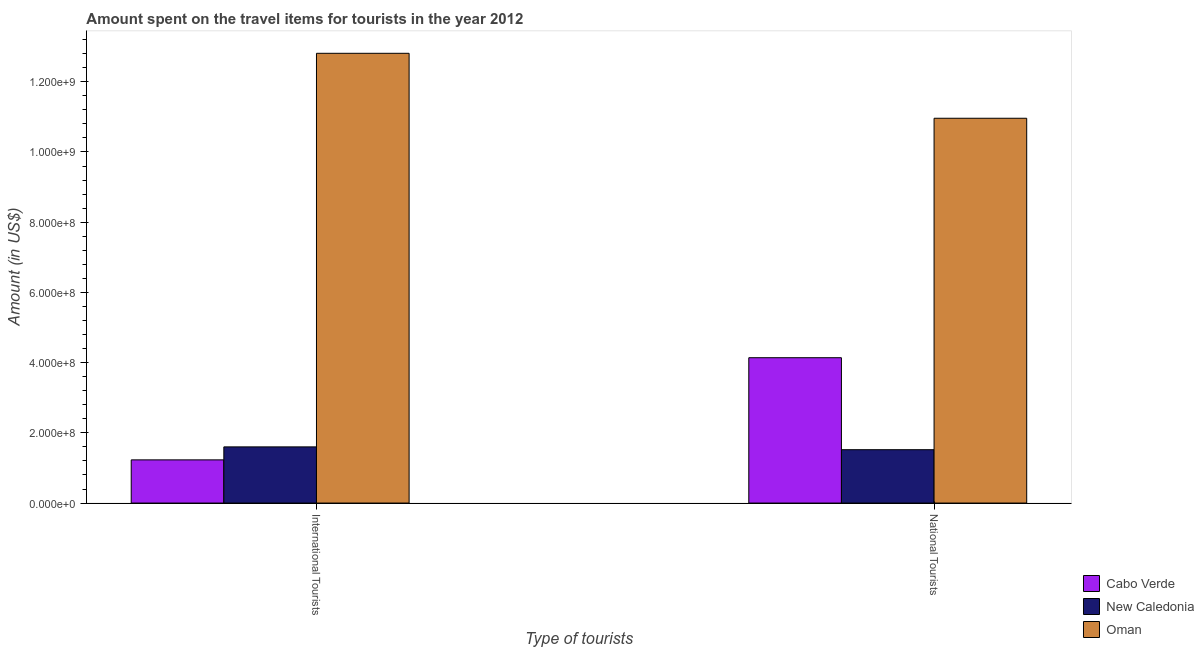How many groups of bars are there?
Your answer should be compact. 2. Are the number of bars on each tick of the X-axis equal?
Provide a short and direct response. Yes. How many bars are there on the 1st tick from the left?
Keep it short and to the point. 3. How many bars are there on the 2nd tick from the right?
Give a very brief answer. 3. What is the label of the 2nd group of bars from the left?
Offer a very short reply. National Tourists. What is the amount spent on travel items of international tourists in Oman?
Keep it short and to the point. 1.28e+09. Across all countries, what is the maximum amount spent on travel items of national tourists?
Provide a succinct answer. 1.10e+09. Across all countries, what is the minimum amount spent on travel items of international tourists?
Your response must be concise. 1.23e+08. In which country was the amount spent on travel items of international tourists maximum?
Offer a terse response. Oman. In which country was the amount spent on travel items of national tourists minimum?
Provide a succinct answer. New Caledonia. What is the total amount spent on travel items of national tourists in the graph?
Offer a very short reply. 1.66e+09. What is the difference between the amount spent on travel items of national tourists in Cabo Verde and that in New Caledonia?
Offer a terse response. 2.62e+08. What is the difference between the amount spent on travel items of international tourists in New Caledonia and the amount spent on travel items of national tourists in Oman?
Provide a succinct answer. -9.36e+08. What is the average amount spent on travel items of international tourists per country?
Provide a short and direct response. 5.21e+08. What is the difference between the amount spent on travel items of national tourists and amount spent on travel items of international tourists in New Caledonia?
Your answer should be compact. -8.00e+06. What is the ratio of the amount spent on travel items of international tourists in New Caledonia to that in Oman?
Ensure brevity in your answer.  0.12. What does the 2nd bar from the left in International Tourists represents?
Provide a short and direct response. New Caledonia. What does the 3rd bar from the right in National Tourists represents?
Provide a succinct answer. Cabo Verde. How many bars are there?
Provide a succinct answer. 6. Are all the bars in the graph horizontal?
Your answer should be compact. No. How many countries are there in the graph?
Offer a very short reply. 3. What is the difference between two consecutive major ticks on the Y-axis?
Offer a terse response. 2.00e+08. Are the values on the major ticks of Y-axis written in scientific E-notation?
Make the answer very short. Yes. How many legend labels are there?
Ensure brevity in your answer.  3. How are the legend labels stacked?
Keep it short and to the point. Vertical. What is the title of the graph?
Your answer should be compact. Amount spent on the travel items for tourists in the year 2012. What is the label or title of the X-axis?
Make the answer very short. Type of tourists. What is the Amount (in US$) in Cabo Verde in International Tourists?
Ensure brevity in your answer.  1.23e+08. What is the Amount (in US$) of New Caledonia in International Tourists?
Your answer should be compact. 1.60e+08. What is the Amount (in US$) of Oman in International Tourists?
Your response must be concise. 1.28e+09. What is the Amount (in US$) in Cabo Verde in National Tourists?
Your response must be concise. 4.14e+08. What is the Amount (in US$) of New Caledonia in National Tourists?
Keep it short and to the point. 1.52e+08. What is the Amount (in US$) in Oman in National Tourists?
Your answer should be very brief. 1.10e+09. Across all Type of tourists, what is the maximum Amount (in US$) of Cabo Verde?
Provide a succinct answer. 4.14e+08. Across all Type of tourists, what is the maximum Amount (in US$) in New Caledonia?
Give a very brief answer. 1.60e+08. Across all Type of tourists, what is the maximum Amount (in US$) of Oman?
Your answer should be very brief. 1.28e+09. Across all Type of tourists, what is the minimum Amount (in US$) of Cabo Verde?
Offer a very short reply. 1.23e+08. Across all Type of tourists, what is the minimum Amount (in US$) of New Caledonia?
Your answer should be very brief. 1.52e+08. Across all Type of tourists, what is the minimum Amount (in US$) in Oman?
Provide a short and direct response. 1.10e+09. What is the total Amount (in US$) of Cabo Verde in the graph?
Provide a short and direct response. 5.37e+08. What is the total Amount (in US$) of New Caledonia in the graph?
Provide a short and direct response. 3.12e+08. What is the total Amount (in US$) in Oman in the graph?
Offer a very short reply. 2.38e+09. What is the difference between the Amount (in US$) of Cabo Verde in International Tourists and that in National Tourists?
Keep it short and to the point. -2.91e+08. What is the difference between the Amount (in US$) in Oman in International Tourists and that in National Tourists?
Keep it short and to the point. 1.85e+08. What is the difference between the Amount (in US$) in Cabo Verde in International Tourists and the Amount (in US$) in New Caledonia in National Tourists?
Offer a terse response. -2.90e+07. What is the difference between the Amount (in US$) of Cabo Verde in International Tourists and the Amount (in US$) of Oman in National Tourists?
Make the answer very short. -9.73e+08. What is the difference between the Amount (in US$) in New Caledonia in International Tourists and the Amount (in US$) in Oman in National Tourists?
Give a very brief answer. -9.36e+08. What is the average Amount (in US$) in Cabo Verde per Type of tourists?
Your answer should be compact. 2.68e+08. What is the average Amount (in US$) of New Caledonia per Type of tourists?
Ensure brevity in your answer.  1.56e+08. What is the average Amount (in US$) in Oman per Type of tourists?
Your answer should be very brief. 1.19e+09. What is the difference between the Amount (in US$) of Cabo Verde and Amount (in US$) of New Caledonia in International Tourists?
Give a very brief answer. -3.70e+07. What is the difference between the Amount (in US$) of Cabo Verde and Amount (in US$) of Oman in International Tourists?
Your response must be concise. -1.16e+09. What is the difference between the Amount (in US$) in New Caledonia and Amount (in US$) in Oman in International Tourists?
Offer a terse response. -1.12e+09. What is the difference between the Amount (in US$) in Cabo Verde and Amount (in US$) in New Caledonia in National Tourists?
Provide a succinct answer. 2.62e+08. What is the difference between the Amount (in US$) in Cabo Verde and Amount (in US$) in Oman in National Tourists?
Provide a short and direct response. -6.82e+08. What is the difference between the Amount (in US$) in New Caledonia and Amount (in US$) in Oman in National Tourists?
Ensure brevity in your answer.  -9.44e+08. What is the ratio of the Amount (in US$) of Cabo Verde in International Tourists to that in National Tourists?
Provide a succinct answer. 0.3. What is the ratio of the Amount (in US$) in New Caledonia in International Tourists to that in National Tourists?
Your answer should be very brief. 1.05. What is the ratio of the Amount (in US$) in Oman in International Tourists to that in National Tourists?
Your response must be concise. 1.17. What is the difference between the highest and the second highest Amount (in US$) of Cabo Verde?
Give a very brief answer. 2.91e+08. What is the difference between the highest and the second highest Amount (in US$) in New Caledonia?
Offer a terse response. 8.00e+06. What is the difference between the highest and the second highest Amount (in US$) of Oman?
Keep it short and to the point. 1.85e+08. What is the difference between the highest and the lowest Amount (in US$) of Cabo Verde?
Give a very brief answer. 2.91e+08. What is the difference between the highest and the lowest Amount (in US$) in New Caledonia?
Your answer should be compact. 8.00e+06. What is the difference between the highest and the lowest Amount (in US$) in Oman?
Your response must be concise. 1.85e+08. 